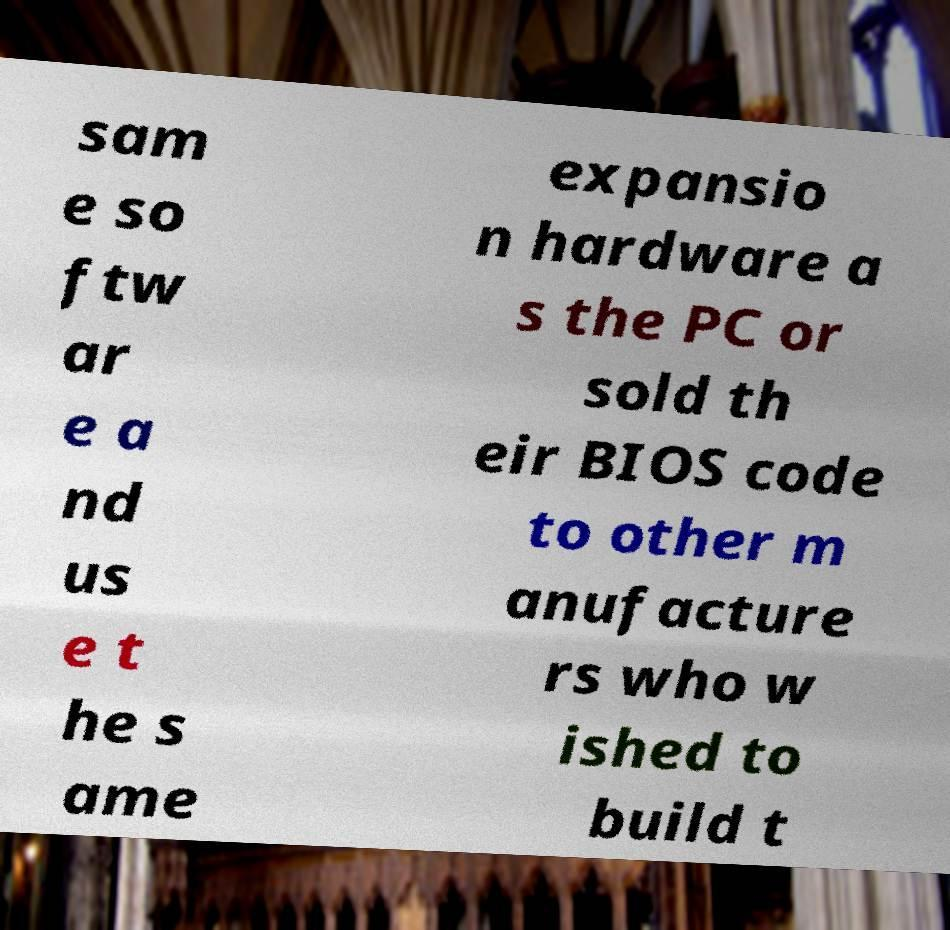Could you extract and type out the text from this image? sam e so ftw ar e a nd us e t he s ame expansio n hardware a s the PC or sold th eir BIOS code to other m anufacture rs who w ished to build t 